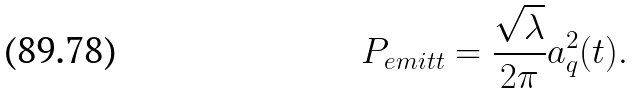Convert formula to latex. <formula><loc_0><loc_0><loc_500><loc_500>P _ { e m i t t } = \frac { \sqrt { \lambda } } { 2 \pi } a ^ { 2 } _ { q } ( t ) .</formula> 